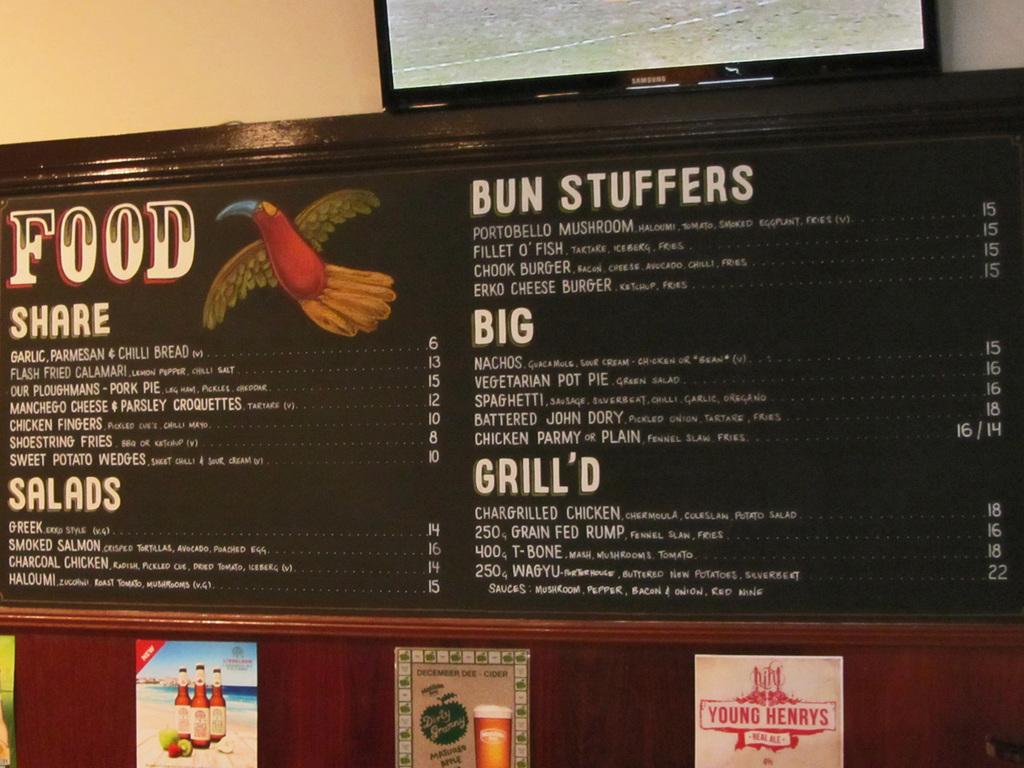How much do the nachos cost?
Give a very brief answer. 15. What kind of ale is being advertised in red?
Ensure brevity in your answer.  Young henrys. 